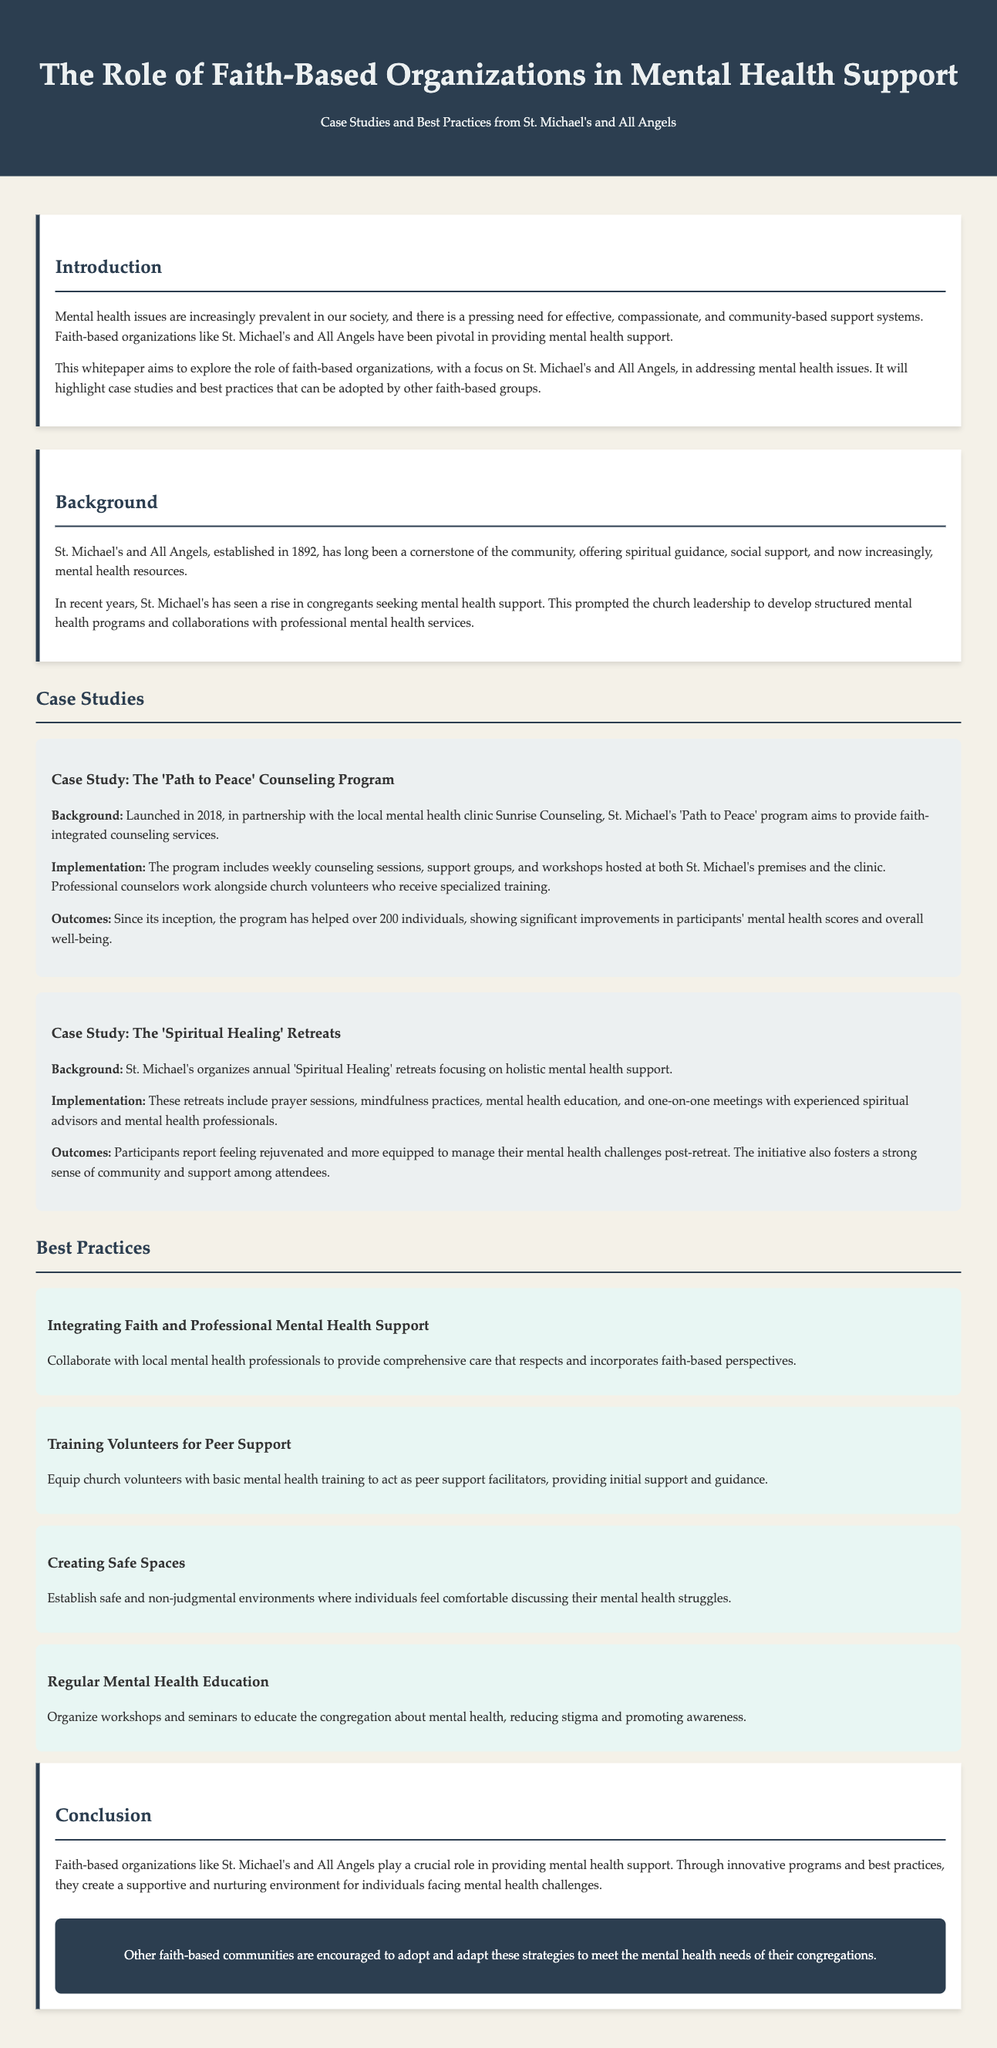what year was St. Michael's and All Angels established? The establishment year is mentioned in the background section of the document.
Answer: 1892 how many individuals have been helped by the 'Path to Peace' program since its inception? The number of individuals helped by this program is specified in the case study.
Answer: over 200 what type of training do church volunteers receive for the 'Path to Peace' program? The type of training is described in the implementation section of the case study.
Answer: specialized training what is one of the outcomes reported by participants of the 'Spiritual Healing' retreats? The outcomes of the retreats are summarized in the case study.
Answer: feeling rejuvenated which practice emphasizes the integration of faith and professional mental health support? The best practice section lists this specific best practice.
Answer: Integrating Faith and Professional Mental Health Support what is a key focus of the annual 'Spiritual Healing' retreats? The focus of the retreats is described in the background section of the case study.
Answer: holistic mental health support how many best practices are listed in the whitepaper? The total number of best practices is specified in the best practices section.
Answer: four what is the role of faith-based organizations like St. Michael's according to the conclusion? The conclusion summarizes the general role of these organizations.
Answer: providing mental health support 